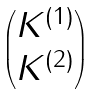Convert formula to latex. <formula><loc_0><loc_0><loc_500><loc_500>\begin{pmatrix} K ^ { ( 1 ) } \\ K ^ { ( 2 ) } \end{pmatrix}</formula> 